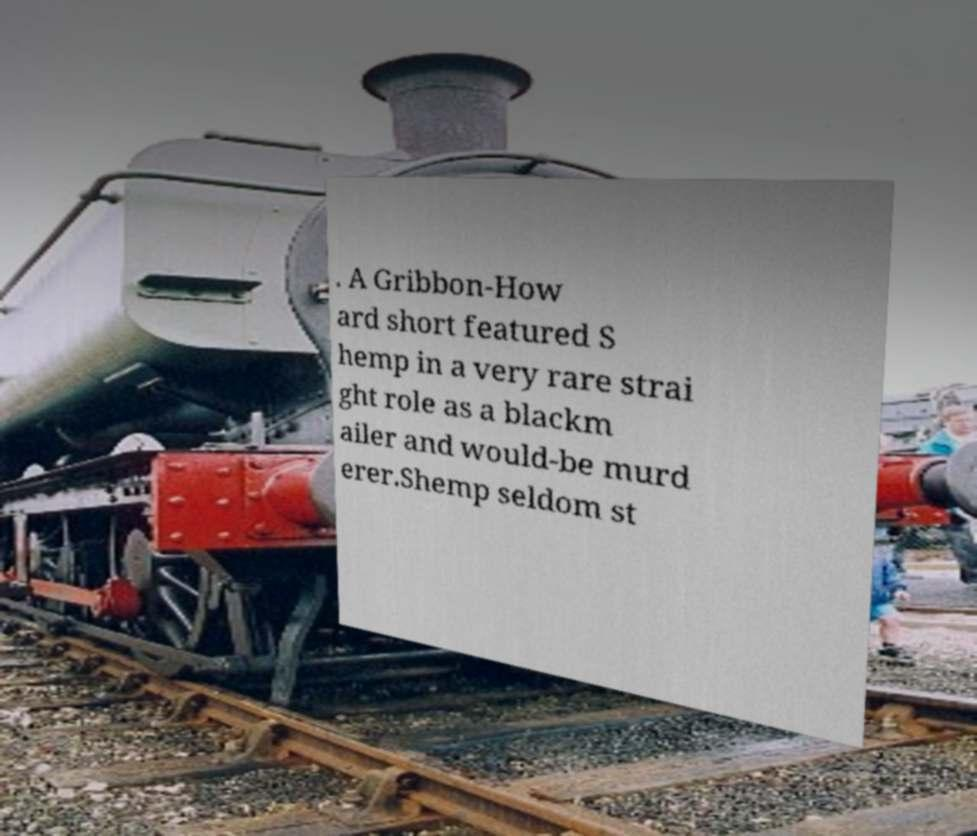Can you read and provide the text displayed in the image?This photo seems to have some interesting text. Can you extract and type it out for me? . A Gribbon-How ard short featured S hemp in a very rare strai ght role as a blackm ailer and would-be murd erer.Shemp seldom st 